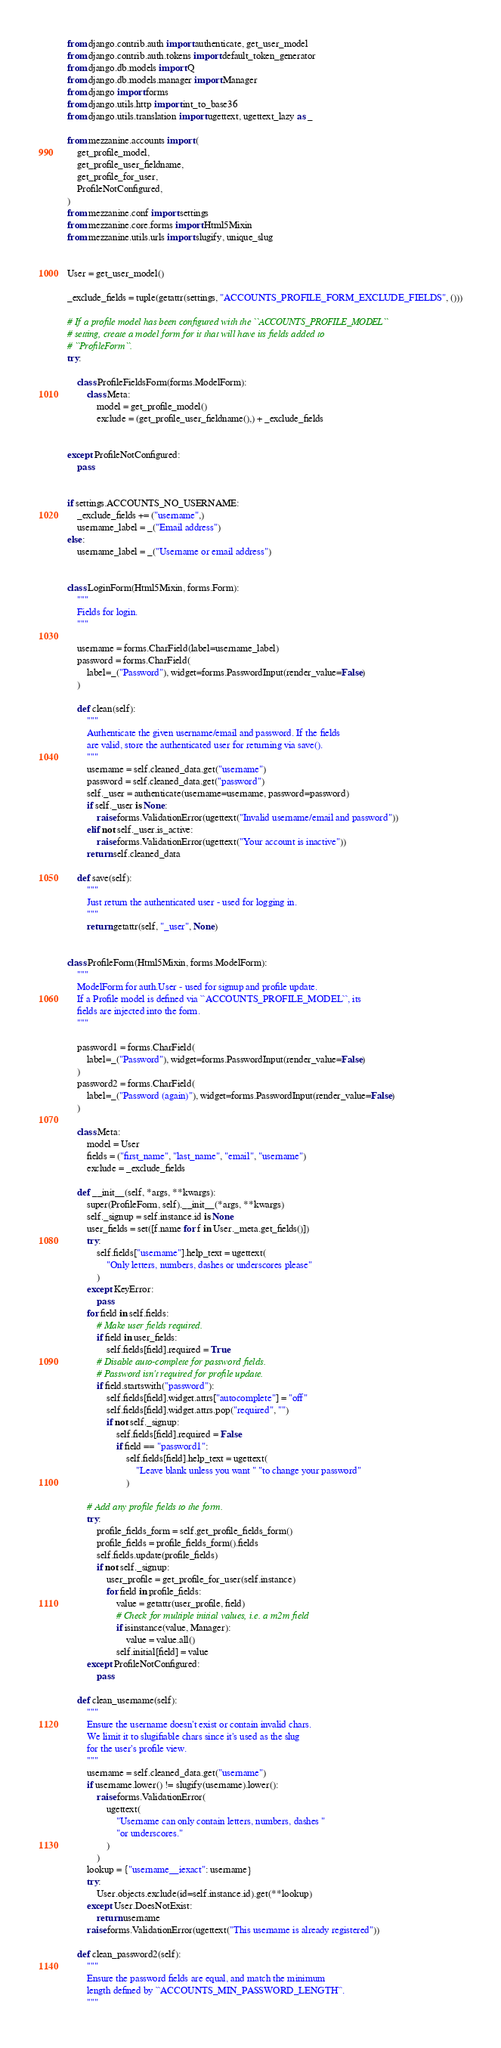Convert code to text. <code><loc_0><loc_0><loc_500><loc_500><_Python_>from django.contrib.auth import authenticate, get_user_model
from django.contrib.auth.tokens import default_token_generator
from django.db.models import Q
from django.db.models.manager import Manager
from django import forms
from django.utils.http import int_to_base36
from django.utils.translation import ugettext, ugettext_lazy as _

from mezzanine.accounts import (
    get_profile_model,
    get_profile_user_fieldname,
    get_profile_for_user,
    ProfileNotConfigured,
)
from mezzanine.conf import settings
from mezzanine.core.forms import Html5Mixin
from mezzanine.utils.urls import slugify, unique_slug


User = get_user_model()

_exclude_fields = tuple(getattr(settings, "ACCOUNTS_PROFILE_FORM_EXCLUDE_FIELDS", ()))

# If a profile model has been configured with the ``ACCOUNTS_PROFILE_MODEL``
# setting, create a model form for it that will have its fields added to
# ``ProfileForm``.
try:

    class ProfileFieldsForm(forms.ModelForm):
        class Meta:
            model = get_profile_model()
            exclude = (get_profile_user_fieldname(),) + _exclude_fields


except ProfileNotConfigured:
    pass


if settings.ACCOUNTS_NO_USERNAME:
    _exclude_fields += ("username",)
    username_label = _("Email address")
else:
    username_label = _("Username or email address")


class LoginForm(Html5Mixin, forms.Form):
    """
    Fields for login.
    """

    username = forms.CharField(label=username_label)
    password = forms.CharField(
        label=_("Password"), widget=forms.PasswordInput(render_value=False)
    )

    def clean(self):
        """
        Authenticate the given username/email and password. If the fields
        are valid, store the authenticated user for returning via save().
        """
        username = self.cleaned_data.get("username")
        password = self.cleaned_data.get("password")
        self._user = authenticate(username=username, password=password)
        if self._user is None:
            raise forms.ValidationError(ugettext("Invalid username/email and password"))
        elif not self._user.is_active:
            raise forms.ValidationError(ugettext("Your account is inactive"))
        return self.cleaned_data

    def save(self):
        """
        Just return the authenticated user - used for logging in.
        """
        return getattr(self, "_user", None)


class ProfileForm(Html5Mixin, forms.ModelForm):
    """
    ModelForm for auth.User - used for signup and profile update.
    If a Profile model is defined via ``ACCOUNTS_PROFILE_MODEL``, its
    fields are injected into the form.
    """

    password1 = forms.CharField(
        label=_("Password"), widget=forms.PasswordInput(render_value=False)
    )
    password2 = forms.CharField(
        label=_("Password (again)"), widget=forms.PasswordInput(render_value=False)
    )

    class Meta:
        model = User
        fields = ("first_name", "last_name", "email", "username")
        exclude = _exclude_fields

    def __init__(self, *args, **kwargs):
        super(ProfileForm, self).__init__(*args, **kwargs)
        self._signup = self.instance.id is None
        user_fields = set([f.name for f in User._meta.get_fields()])
        try:
            self.fields["username"].help_text = ugettext(
                "Only letters, numbers, dashes or underscores please"
            )
        except KeyError:
            pass
        for field in self.fields:
            # Make user fields required.
            if field in user_fields:
                self.fields[field].required = True
            # Disable auto-complete for password fields.
            # Password isn't required for profile update.
            if field.startswith("password"):
                self.fields[field].widget.attrs["autocomplete"] = "off"
                self.fields[field].widget.attrs.pop("required", "")
                if not self._signup:
                    self.fields[field].required = False
                    if field == "password1":
                        self.fields[field].help_text = ugettext(
                            "Leave blank unless you want " "to change your password"
                        )

        # Add any profile fields to the form.
        try:
            profile_fields_form = self.get_profile_fields_form()
            profile_fields = profile_fields_form().fields
            self.fields.update(profile_fields)
            if not self._signup:
                user_profile = get_profile_for_user(self.instance)
                for field in profile_fields:
                    value = getattr(user_profile, field)
                    # Check for multiple initial values, i.e. a m2m field
                    if isinstance(value, Manager):
                        value = value.all()
                    self.initial[field] = value
        except ProfileNotConfigured:
            pass

    def clean_username(self):
        """
        Ensure the username doesn't exist or contain invalid chars.
        We limit it to slugifiable chars since it's used as the slug
        for the user's profile view.
        """
        username = self.cleaned_data.get("username")
        if username.lower() != slugify(username).lower():
            raise forms.ValidationError(
                ugettext(
                    "Username can only contain letters, numbers, dashes "
                    "or underscores."
                )
            )
        lookup = {"username__iexact": username}
        try:
            User.objects.exclude(id=self.instance.id).get(**lookup)
        except User.DoesNotExist:
            return username
        raise forms.ValidationError(ugettext("This username is already registered"))

    def clean_password2(self):
        """
        Ensure the password fields are equal, and match the minimum
        length defined by ``ACCOUNTS_MIN_PASSWORD_LENGTH``.
        """</code> 